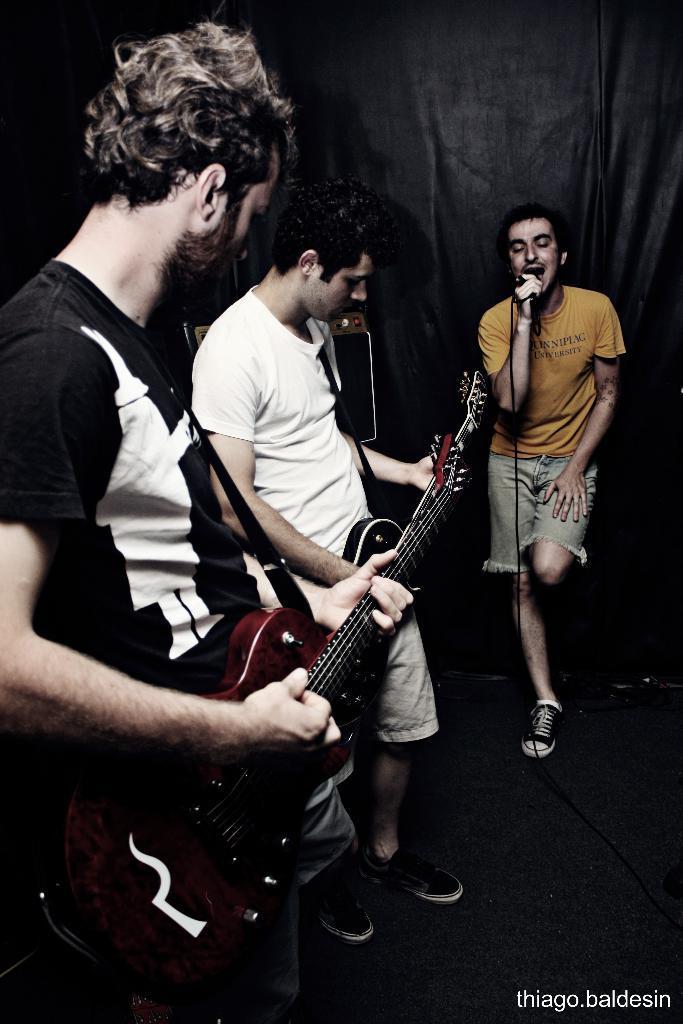Describe this image in one or two sentences. In this image, we can see two people are playing musical instrument, right side the person is singing in-front of microphone. At the back side, we can see black color cloth and some box here. 